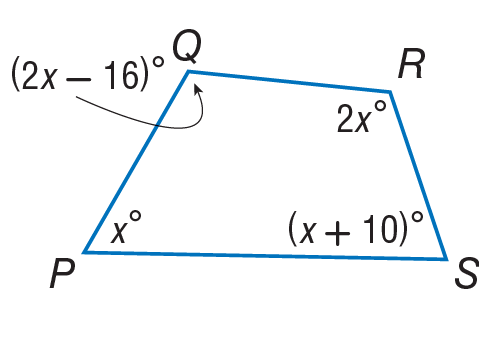Answer the mathemtical geometry problem and directly provide the correct option letter.
Question: Find the measure of \angle P.
Choices: A: 61 B: 71 C: 106 D: 122 A 